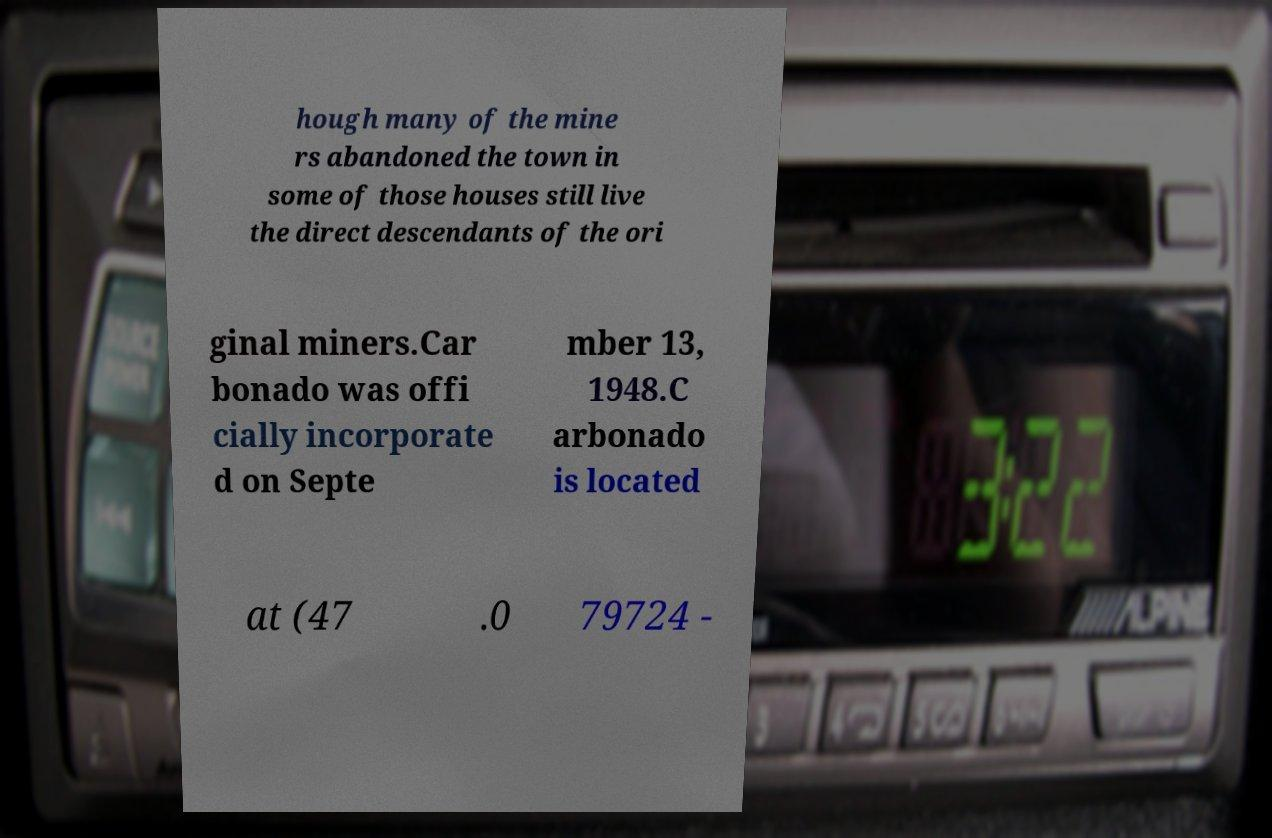Please read and relay the text visible in this image. What does it say? hough many of the mine rs abandoned the town in some of those houses still live the direct descendants of the ori ginal miners.Car bonado was offi cially incorporate d on Septe mber 13, 1948.C arbonado is located at (47 .0 79724 - 